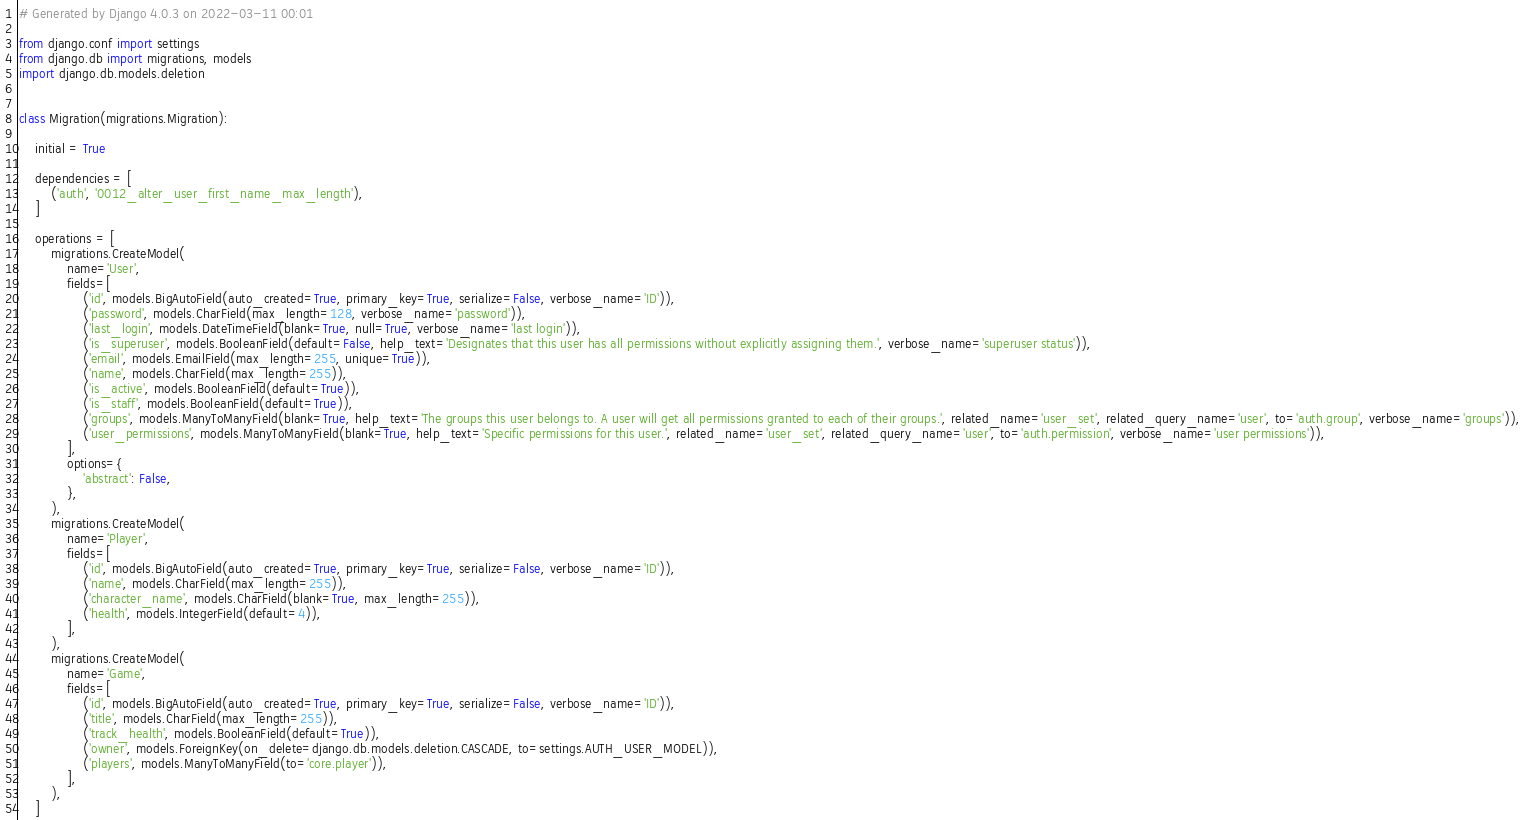Convert code to text. <code><loc_0><loc_0><loc_500><loc_500><_Python_># Generated by Django 4.0.3 on 2022-03-11 00:01

from django.conf import settings
from django.db import migrations, models
import django.db.models.deletion


class Migration(migrations.Migration):

    initial = True

    dependencies = [
        ('auth', '0012_alter_user_first_name_max_length'),
    ]

    operations = [
        migrations.CreateModel(
            name='User',
            fields=[
                ('id', models.BigAutoField(auto_created=True, primary_key=True, serialize=False, verbose_name='ID')),
                ('password', models.CharField(max_length=128, verbose_name='password')),
                ('last_login', models.DateTimeField(blank=True, null=True, verbose_name='last login')),
                ('is_superuser', models.BooleanField(default=False, help_text='Designates that this user has all permissions without explicitly assigning them.', verbose_name='superuser status')),
                ('email', models.EmailField(max_length=255, unique=True)),
                ('name', models.CharField(max_length=255)),
                ('is_active', models.BooleanField(default=True)),
                ('is_staff', models.BooleanField(default=True)),
                ('groups', models.ManyToManyField(blank=True, help_text='The groups this user belongs to. A user will get all permissions granted to each of their groups.', related_name='user_set', related_query_name='user', to='auth.group', verbose_name='groups')),
                ('user_permissions', models.ManyToManyField(blank=True, help_text='Specific permissions for this user.', related_name='user_set', related_query_name='user', to='auth.permission', verbose_name='user permissions')),
            ],
            options={
                'abstract': False,
            },
        ),
        migrations.CreateModel(
            name='Player',
            fields=[
                ('id', models.BigAutoField(auto_created=True, primary_key=True, serialize=False, verbose_name='ID')),
                ('name', models.CharField(max_length=255)),
                ('character_name', models.CharField(blank=True, max_length=255)),
                ('health', models.IntegerField(default=4)),
            ],
        ),
        migrations.CreateModel(
            name='Game',
            fields=[
                ('id', models.BigAutoField(auto_created=True, primary_key=True, serialize=False, verbose_name='ID')),
                ('title', models.CharField(max_length=255)),
                ('track_health', models.BooleanField(default=True)),
                ('owner', models.ForeignKey(on_delete=django.db.models.deletion.CASCADE, to=settings.AUTH_USER_MODEL)),
                ('players', models.ManyToManyField(to='core.player')),
            ],
        ),
    ]
</code> 